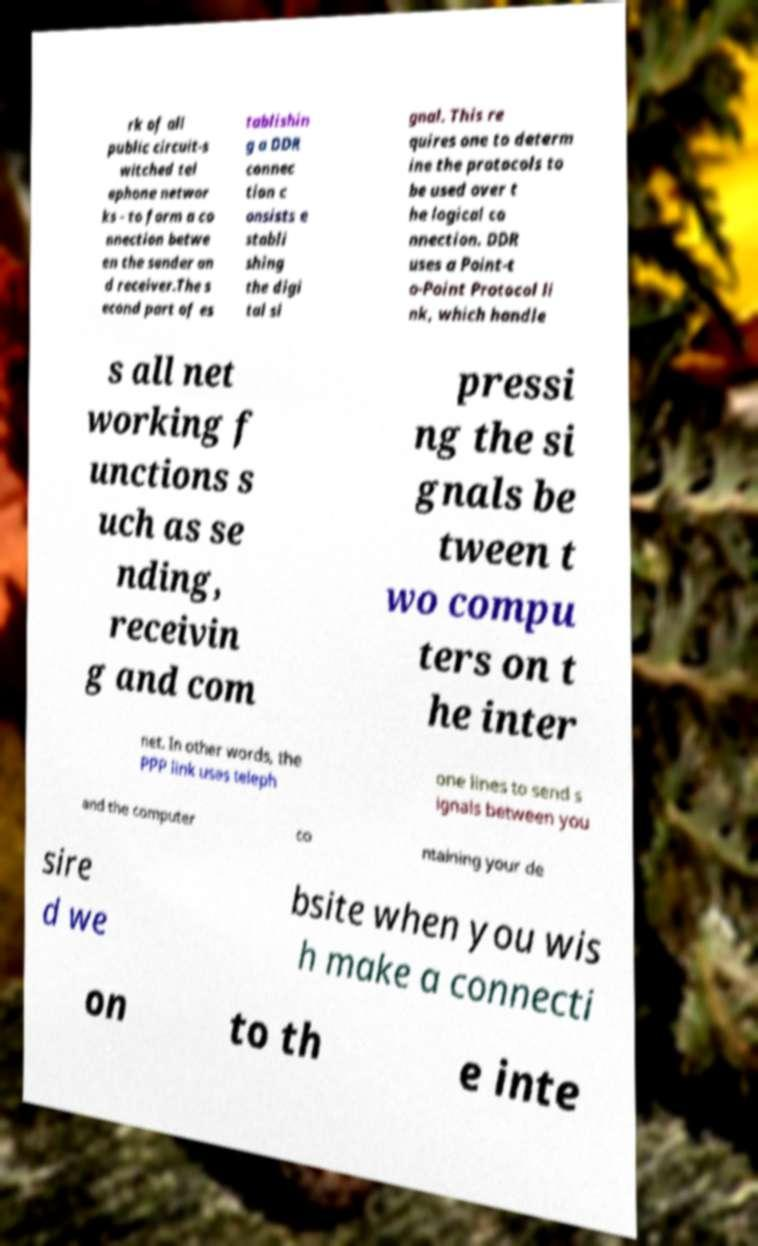There's text embedded in this image that I need extracted. Can you transcribe it verbatim? rk of all public circuit-s witched tel ephone networ ks - to form a co nnection betwe en the sender an d receiver.The s econd part of es tablishin g a DDR connec tion c onsists e stabli shing the digi tal si gnal. This re quires one to determ ine the protocols to be used over t he logical co nnection. DDR uses a Point-t o-Point Protocol li nk, which handle s all net working f unctions s uch as se nding, receivin g and com pressi ng the si gnals be tween t wo compu ters on t he inter net. In other words, the PPP link uses teleph one lines to send s ignals between you and the computer co ntaining your de sire d we bsite when you wis h make a connecti on to th e inte 